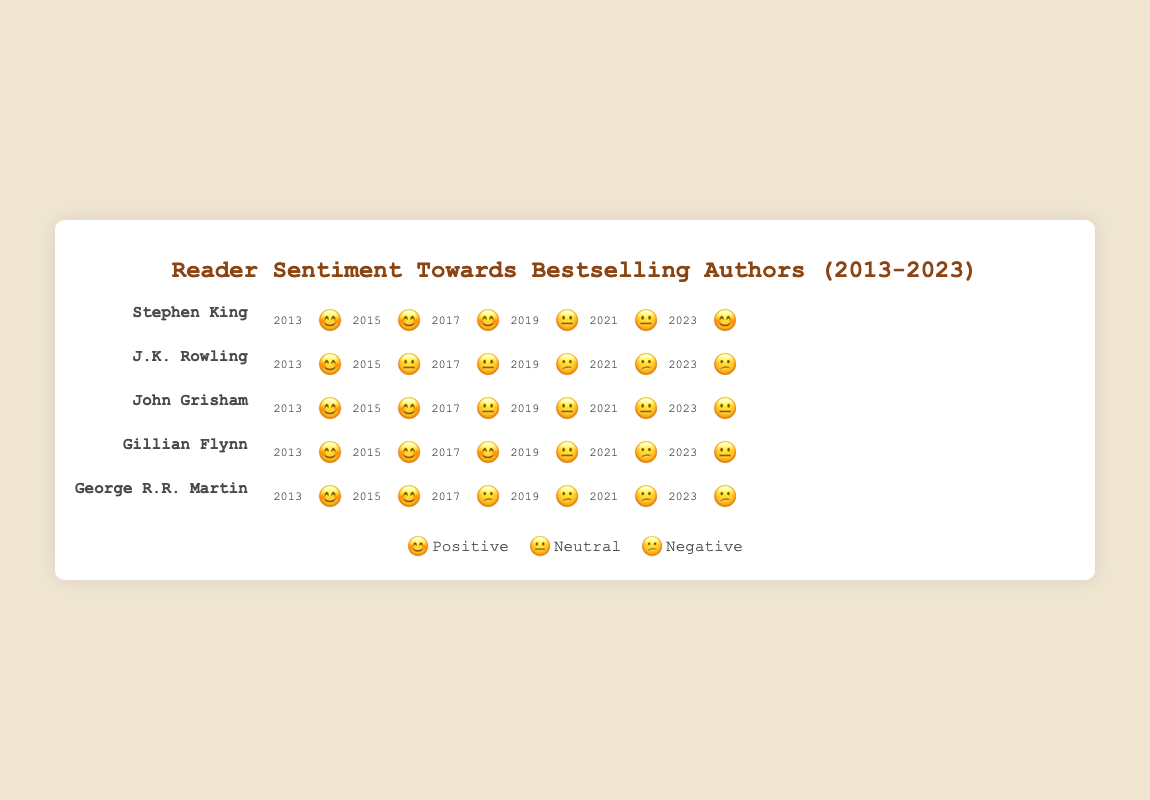What is the overall sentiment trend for J.K. Rowling from 2013 to 2023? Compare the emojis for J.K. Rowling across the years. In 2013, the emoji is 😊 (Positive). By 2023, it changes to 😕 (Negative) showing a decline in sentiment.
Answer: Negative How did reader sentiment for Stephen King change between 2017 and 2019? In 2017, the sentiment for Stephen King is 😊 (Positive), and it changes to 😐 (Neutral) in 2019, indicating a shift from positive to neutral.
Answer: Neutral Which author had the most consistent reader sentiment from 2013 to 2023? To find the most consistent reader sentiment, look for the author whose emojis have the least variation. John Grisham's emojis show a shift from 😊 (Positive) to 😐 (Neutral) early and then remain 😐 throughout.
Answer: John Grisham What year did Gillian Flynn's sentiment turn to negative? Check the timeline for Gillian Flynn and find the first year with a 😕 (Negative) emoji. This occurs in 2021.
Answer: 2021 In 2015, how many authors had a positive sentiment? Review the 2015 row emojis and count the number of 😊 (Positive) emojis. The authors are Stephen King, John Grisham, Gillian Flynn, and George R.R. Martin, totaling 4.
Answer: 4 Which author had a negative sentiment in 2017? Check the emojis for 2017 and see which author has a 😕 (Negative) emoji. George R.R. Martin has a negative sentiment in 2017.
Answer: George R.R. Martin How many authors had a neutral sentiment in both 2017 and 2023? Count the neutral 😐 emojis for each author in both years (2017 and 2023). John Grisham had neutral sentiment in both years.
Answer: 1 Between 2013 and 2021, who experienced the least sentiment decline? Compare the emojis from 2013 to 2021 for each author to determine who had the smallest change from positive 😊. Stephen King and John Grisham shifted from 😊 to 😐, which indicates the least decline (one step towards neutral).
Answer: Stephen King, John Grisham 